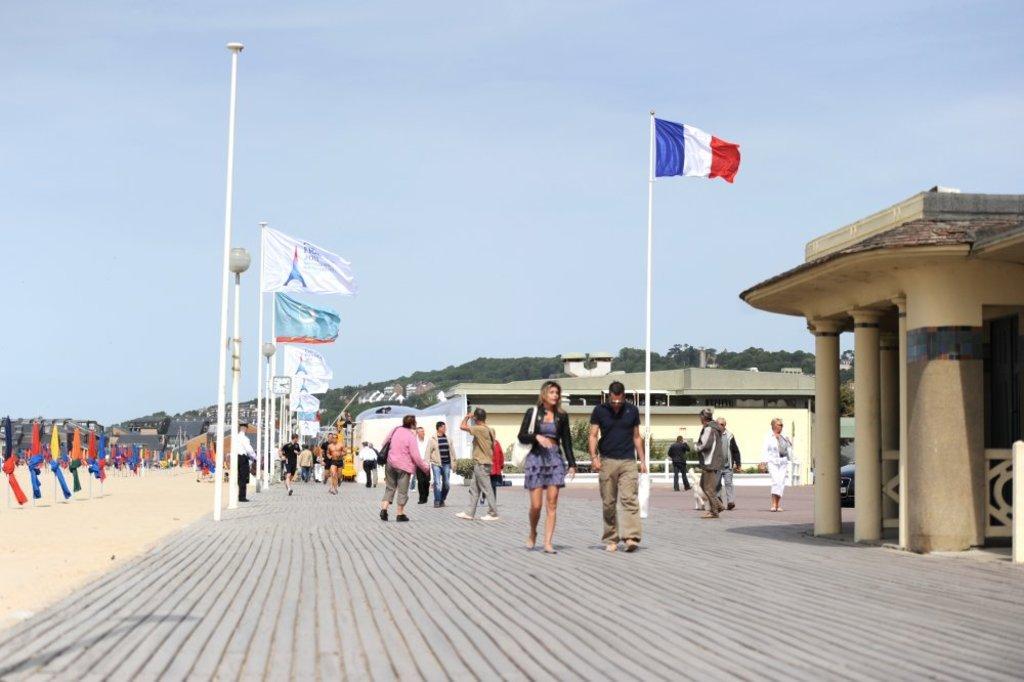Can you describe this image briefly? In the image we can see there are people standing on the footpath and there are flags tied to the pole. Beside there are buildings and there is sand on the other side. 